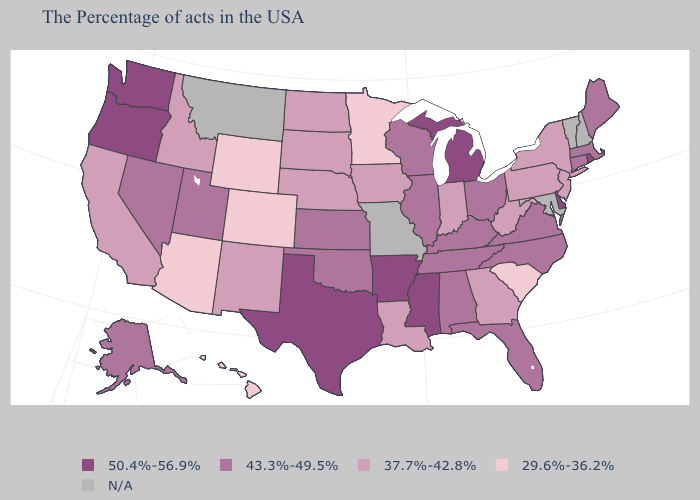Name the states that have a value in the range 43.3%-49.5%?
Write a very short answer. Maine, Massachusetts, Connecticut, Virginia, North Carolina, Ohio, Florida, Kentucky, Alabama, Tennessee, Wisconsin, Illinois, Kansas, Oklahoma, Utah, Nevada, Alaska. Does the map have missing data?
Answer briefly. Yes. Does Pennsylvania have the highest value in the USA?
Concise answer only. No. Which states hav the highest value in the Northeast?
Quick response, please. Rhode Island. Does Mississippi have the highest value in the USA?
Be succinct. Yes. What is the value of New Hampshire?
Answer briefly. N/A. Does the first symbol in the legend represent the smallest category?
Short answer required. No. What is the value of Nebraska?
Concise answer only. 37.7%-42.8%. Does Michigan have the lowest value in the USA?
Answer briefly. No. Which states have the highest value in the USA?
Answer briefly. Rhode Island, Delaware, Michigan, Mississippi, Arkansas, Texas, Washington, Oregon. Among the states that border Massachusetts , which have the lowest value?
Quick response, please. New York. Among the states that border Rhode Island , which have the lowest value?
Short answer required. Massachusetts, Connecticut. What is the highest value in the USA?
Write a very short answer. 50.4%-56.9%. What is the value of Louisiana?
Give a very brief answer. 37.7%-42.8%. 